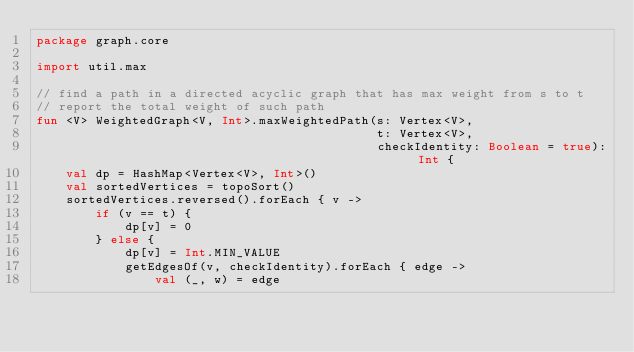<code> <loc_0><loc_0><loc_500><loc_500><_Kotlin_>package graph.core

import util.max

// find a path in a directed acyclic graph that has max weight from s to t
// report the total weight of such path
fun <V> WeightedGraph<V, Int>.maxWeightedPath(s: Vertex<V>,
                                              t: Vertex<V>,
                                              checkIdentity: Boolean = true): Int {
	val dp = HashMap<Vertex<V>, Int>()
	val sortedVertices = topoSort()
	sortedVertices.reversed().forEach { v ->
		if (v == t) {
			dp[v] = 0
		} else {
			dp[v] = Int.MIN_VALUE
			getEdgesOf(v, checkIdentity).forEach { edge ->
				val (_, w) = edge</code> 